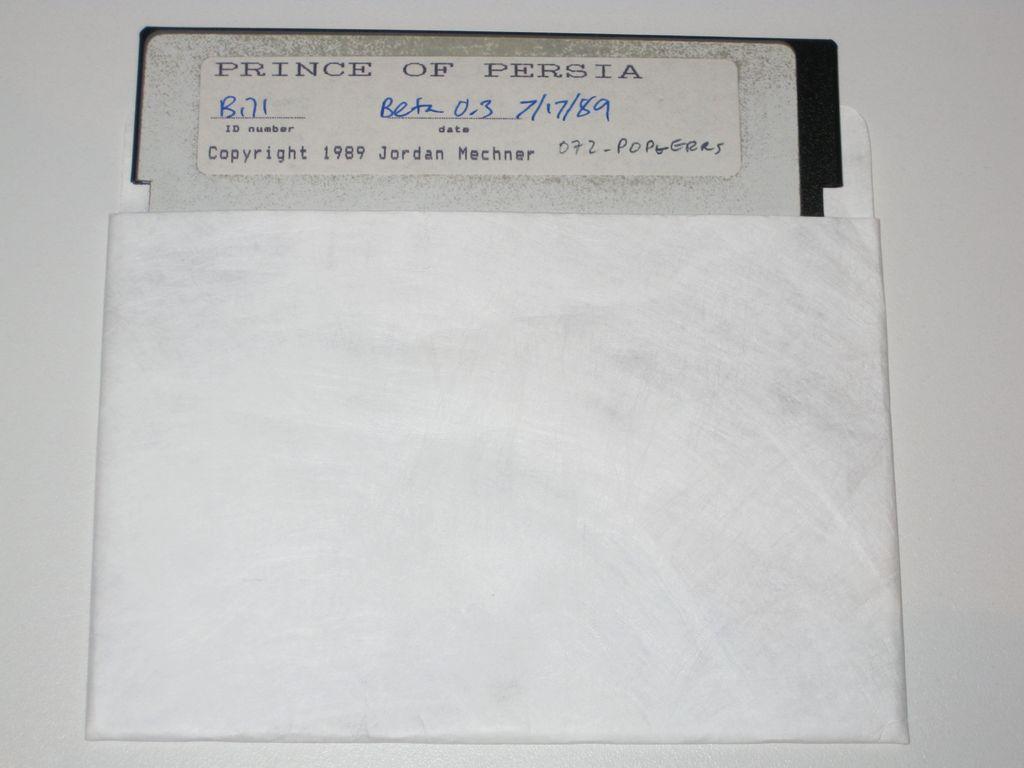Is this an old copy of the game?
Your answer should be very brief. Yes. What year was this copyrighted?
Make the answer very short. 1989. 